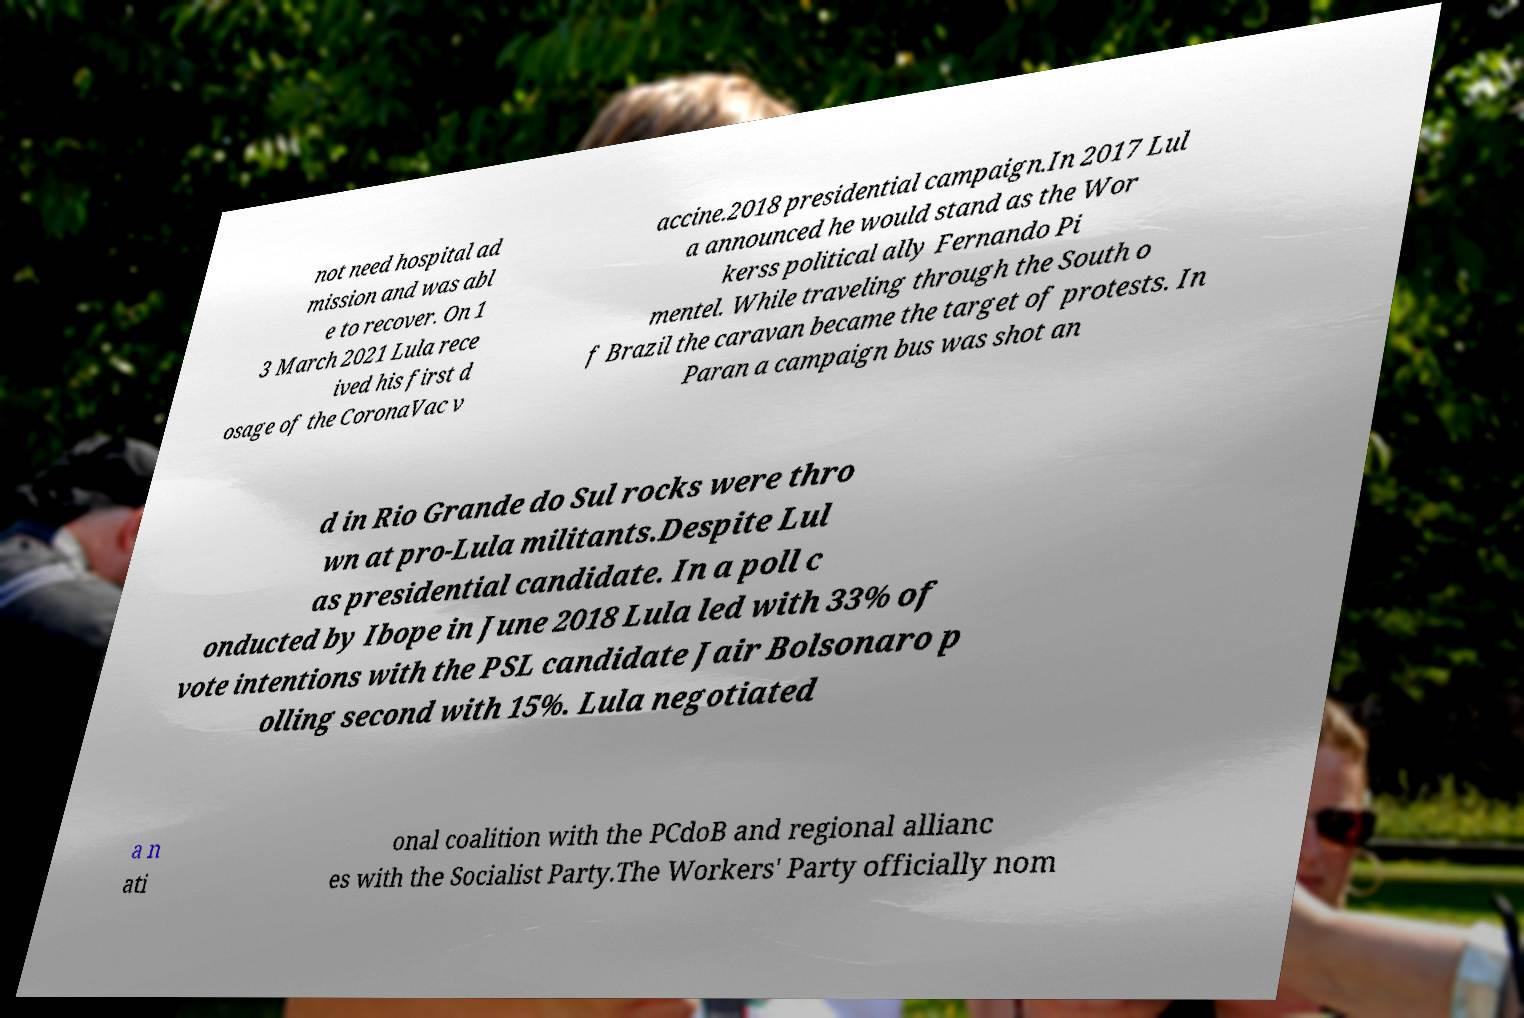Could you extract and type out the text from this image? not need hospital ad mission and was abl e to recover. On 1 3 March 2021 Lula rece ived his first d osage of the CoronaVac v accine.2018 presidential campaign.In 2017 Lul a announced he would stand as the Wor kerss political ally Fernando Pi mentel. While traveling through the South o f Brazil the caravan became the target of protests. In Paran a campaign bus was shot an d in Rio Grande do Sul rocks were thro wn at pro-Lula militants.Despite Lul as presidential candidate. In a poll c onducted by Ibope in June 2018 Lula led with 33% of vote intentions with the PSL candidate Jair Bolsonaro p olling second with 15%. Lula negotiated a n ati onal coalition with the PCdoB and regional allianc es with the Socialist Party.The Workers' Party officially nom 